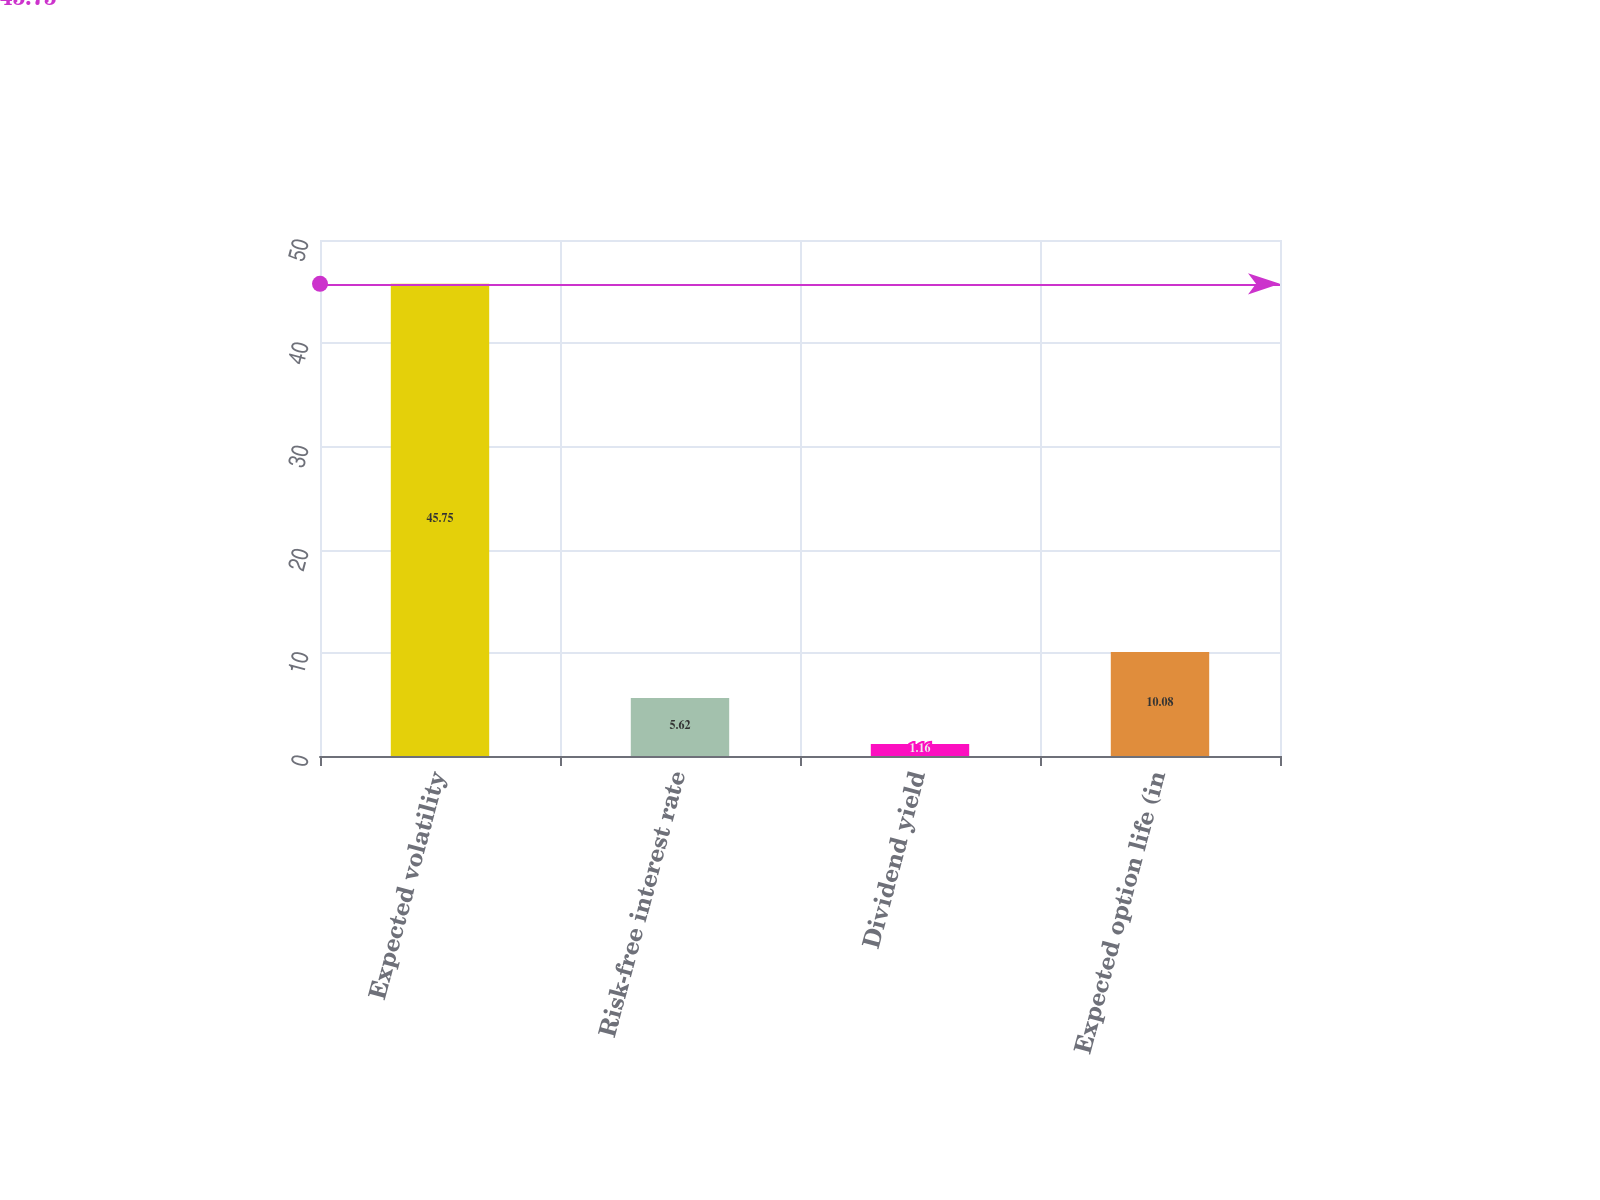Convert chart. <chart><loc_0><loc_0><loc_500><loc_500><bar_chart><fcel>Expected volatility<fcel>Risk-free interest rate<fcel>Dividend yield<fcel>Expected option life (in<nl><fcel>45.75<fcel>5.62<fcel>1.16<fcel>10.08<nl></chart> 